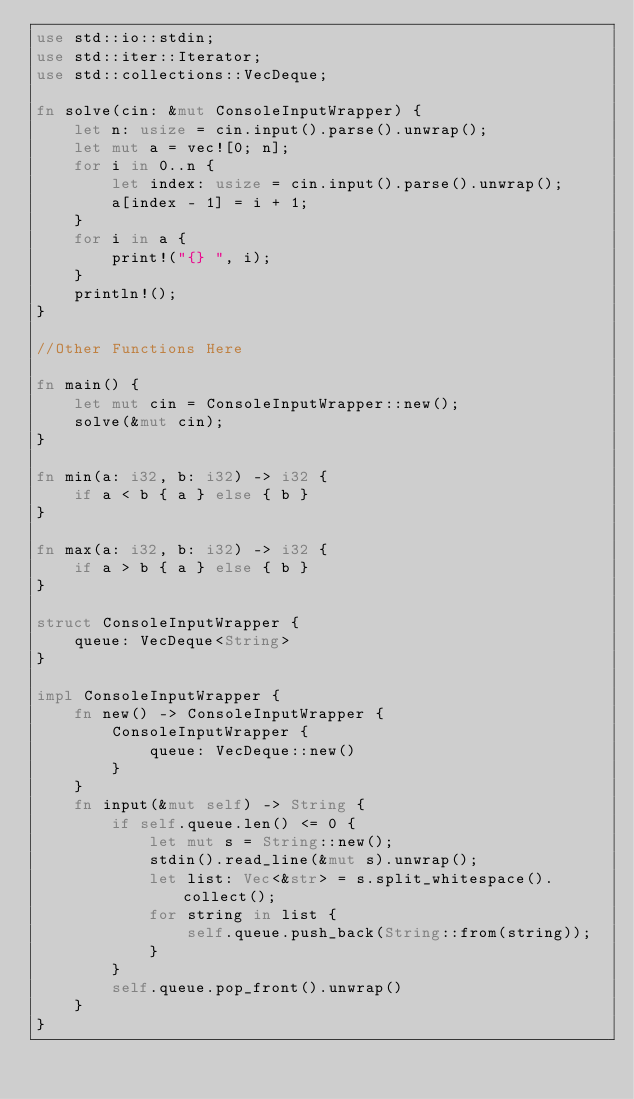<code> <loc_0><loc_0><loc_500><loc_500><_Rust_>use std::io::stdin;
use std::iter::Iterator;
use std::collections::VecDeque;

fn solve(cin: &mut ConsoleInputWrapper) {
    let n: usize = cin.input().parse().unwrap();
    let mut a = vec![0; n];
    for i in 0..n {
        let index: usize = cin.input().parse().unwrap();
        a[index - 1] = i + 1;
    }
    for i in a {
        print!("{} ", i);
    }
    println!();
}

//Other Functions Here

fn main() {
    let mut cin = ConsoleInputWrapper::new();
    solve(&mut cin);
}

fn min(a: i32, b: i32) -> i32 {
    if a < b { a } else { b }
}

fn max(a: i32, b: i32) -> i32 {
    if a > b { a } else { b }
}

struct ConsoleInputWrapper {
    queue: VecDeque<String>
}

impl ConsoleInputWrapper {
    fn new() -> ConsoleInputWrapper {
        ConsoleInputWrapper {
            queue: VecDeque::new()
        }
    }
    fn input(&mut self) -> String {
        if self.queue.len() <= 0 {
            let mut s = String::new();
            stdin().read_line(&mut s).unwrap();
            let list: Vec<&str> = s.split_whitespace().collect();
            for string in list {
                self.queue.push_back(String::from(string));
            }
        }
        self.queue.pop_front().unwrap()
    }
}</code> 